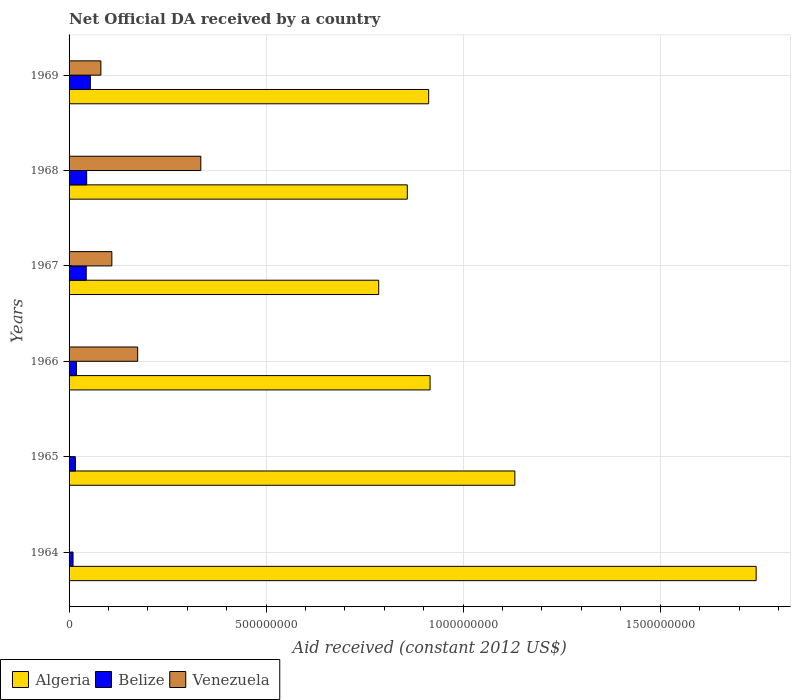How many different coloured bars are there?
Your answer should be very brief. 3. How many groups of bars are there?
Give a very brief answer. 6. Are the number of bars per tick equal to the number of legend labels?
Provide a succinct answer. No. Are the number of bars on each tick of the Y-axis equal?
Make the answer very short. No. How many bars are there on the 4th tick from the top?
Your answer should be compact. 3. What is the label of the 1st group of bars from the top?
Give a very brief answer. 1969. In how many cases, is the number of bars for a given year not equal to the number of legend labels?
Give a very brief answer. 2. What is the net official development assistance aid received in Venezuela in 1965?
Your answer should be compact. 0. Across all years, what is the maximum net official development assistance aid received in Belize?
Offer a very short reply. 5.40e+07. Across all years, what is the minimum net official development assistance aid received in Belize?
Offer a very short reply. 1.01e+07. In which year was the net official development assistance aid received in Venezuela maximum?
Ensure brevity in your answer.  1968. What is the total net official development assistance aid received in Venezuela in the graph?
Give a very brief answer. 6.98e+08. What is the difference between the net official development assistance aid received in Algeria in 1964 and that in 1965?
Make the answer very short. 6.12e+08. What is the difference between the net official development assistance aid received in Venezuela in 1967 and the net official development assistance aid received in Belize in 1968?
Your answer should be very brief. 6.39e+07. What is the average net official development assistance aid received in Belize per year?
Keep it short and to the point. 3.12e+07. In the year 1967, what is the difference between the net official development assistance aid received in Algeria and net official development assistance aid received in Venezuela?
Your answer should be very brief. 6.77e+08. What is the ratio of the net official development assistance aid received in Belize in 1965 to that in 1967?
Ensure brevity in your answer.  0.37. Is the difference between the net official development assistance aid received in Algeria in 1968 and 1969 greater than the difference between the net official development assistance aid received in Venezuela in 1968 and 1969?
Your response must be concise. No. What is the difference between the highest and the second highest net official development assistance aid received in Belize?
Make the answer very short. 9.25e+06. What is the difference between the highest and the lowest net official development assistance aid received in Algeria?
Your answer should be compact. 9.58e+08. In how many years, is the net official development assistance aid received in Algeria greater than the average net official development assistance aid received in Algeria taken over all years?
Keep it short and to the point. 2. How many bars are there?
Your response must be concise. 16. Are all the bars in the graph horizontal?
Ensure brevity in your answer.  Yes. What is the difference between two consecutive major ticks on the X-axis?
Your answer should be very brief. 5.00e+08. Are the values on the major ticks of X-axis written in scientific E-notation?
Keep it short and to the point. No. Does the graph contain grids?
Offer a very short reply. Yes. What is the title of the graph?
Give a very brief answer. Net Official DA received by a country. Does "Ghana" appear as one of the legend labels in the graph?
Your answer should be very brief. No. What is the label or title of the X-axis?
Offer a terse response. Aid received (constant 2012 US$). What is the label or title of the Y-axis?
Provide a succinct answer. Years. What is the Aid received (constant 2012 US$) of Algeria in 1964?
Offer a terse response. 1.74e+09. What is the Aid received (constant 2012 US$) of Belize in 1964?
Provide a succinct answer. 1.01e+07. What is the Aid received (constant 2012 US$) in Venezuela in 1964?
Your response must be concise. 0. What is the Aid received (constant 2012 US$) of Algeria in 1965?
Provide a succinct answer. 1.13e+09. What is the Aid received (constant 2012 US$) in Belize in 1965?
Your answer should be very brief. 1.60e+07. What is the Aid received (constant 2012 US$) of Venezuela in 1965?
Make the answer very short. 0. What is the Aid received (constant 2012 US$) of Algeria in 1966?
Your answer should be compact. 9.16e+08. What is the Aid received (constant 2012 US$) in Belize in 1966?
Your answer should be compact. 1.88e+07. What is the Aid received (constant 2012 US$) of Venezuela in 1966?
Keep it short and to the point. 1.74e+08. What is the Aid received (constant 2012 US$) of Algeria in 1967?
Offer a very short reply. 7.86e+08. What is the Aid received (constant 2012 US$) of Belize in 1967?
Offer a terse response. 4.36e+07. What is the Aid received (constant 2012 US$) of Venezuela in 1967?
Your answer should be compact. 1.09e+08. What is the Aid received (constant 2012 US$) in Algeria in 1968?
Provide a short and direct response. 8.58e+08. What is the Aid received (constant 2012 US$) of Belize in 1968?
Make the answer very short. 4.47e+07. What is the Aid received (constant 2012 US$) in Venezuela in 1968?
Keep it short and to the point. 3.34e+08. What is the Aid received (constant 2012 US$) in Algeria in 1969?
Make the answer very short. 9.12e+08. What is the Aid received (constant 2012 US$) in Belize in 1969?
Your response must be concise. 5.40e+07. What is the Aid received (constant 2012 US$) of Venezuela in 1969?
Provide a succinct answer. 8.07e+07. Across all years, what is the maximum Aid received (constant 2012 US$) in Algeria?
Give a very brief answer. 1.74e+09. Across all years, what is the maximum Aid received (constant 2012 US$) of Belize?
Your answer should be compact. 5.40e+07. Across all years, what is the maximum Aid received (constant 2012 US$) of Venezuela?
Keep it short and to the point. 3.34e+08. Across all years, what is the minimum Aid received (constant 2012 US$) in Algeria?
Keep it short and to the point. 7.86e+08. Across all years, what is the minimum Aid received (constant 2012 US$) in Belize?
Provide a succinct answer. 1.01e+07. What is the total Aid received (constant 2012 US$) in Algeria in the graph?
Your answer should be compact. 6.35e+09. What is the total Aid received (constant 2012 US$) of Belize in the graph?
Offer a very short reply. 1.87e+08. What is the total Aid received (constant 2012 US$) in Venezuela in the graph?
Give a very brief answer. 6.98e+08. What is the difference between the Aid received (constant 2012 US$) in Algeria in 1964 and that in 1965?
Provide a short and direct response. 6.12e+08. What is the difference between the Aid received (constant 2012 US$) in Belize in 1964 and that in 1965?
Offer a very short reply. -5.88e+06. What is the difference between the Aid received (constant 2012 US$) in Algeria in 1964 and that in 1966?
Make the answer very short. 8.27e+08. What is the difference between the Aid received (constant 2012 US$) in Belize in 1964 and that in 1966?
Keep it short and to the point. -8.71e+06. What is the difference between the Aid received (constant 2012 US$) in Algeria in 1964 and that in 1967?
Give a very brief answer. 9.58e+08. What is the difference between the Aid received (constant 2012 US$) of Belize in 1964 and that in 1967?
Keep it short and to the point. -3.35e+07. What is the difference between the Aid received (constant 2012 US$) in Algeria in 1964 and that in 1968?
Ensure brevity in your answer.  8.85e+08. What is the difference between the Aid received (constant 2012 US$) in Belize in 1964 and that in 1968?
Keep it short and to the point. -3.46e+07. What is the difference between the Aid received (constant 2012 US$) in Algeria in 1964 and that in 1969?
Offer a terse response. 8.31e+08. What is the difference between the Aid received (constant 2012 US$) of Belize in 1964 and that in 1969?
Ensure brevity in your answer.  -4.39e+07. What is the difference between the Aid received (constant 2012 US$) in Algeria in 1965 and that in 1966?
Offer a terse response. 2.15e+08. What is the difference between the Aid received (constant 2012 US$) of Belize in 1965 and that in 1966?
Offer a very short reply. -2.83e+06. What is the difference between the Aid received (constant 2012 US$) of Algeria in 1965 and that in 1967?
Your answer should be very brief. 3.45e+08. What is the difference between the Aid received (constant 2012 US$) of Belize in 1965 and that in 1967?
Your response must be concise. -2.76e+07. What is the difference between the Aid received (constant 2012 US$) of Algeria in 1965 and that in 1968?
Offer a very short reply. 2.73e+08. What is the difference between the Aid received (constant 2012 US$) in Belize in 1965 and that in 1968?
Make the answer very short. -2.87e+07. What is the difference between the Aid received (constant 2012 US$) of Algeria in 1965 and that in 1969?
Give a very brief answer. 2.19e+08. What is the difference between the Aid received (constant 2012 US$) in Belize in 1965 and that in 1969?
Make the answer very short. -3.80e+07. What is the difference between the Aid received (constant 2012 US$) of Algeria in 1966 and that in 1967?
Your answer should be very brief. 1.30e+08. What is the difference between the Aid received (constant 2012 US$) of Belize in 1966 and that in 1967?
Offer a terse response. -2.48e+07. What is the difference between the Aid received (constant 2012 US$) of Venezuela in 1966 and that in 1967?
Offer a terse response. 6.55e+07. What is the difference between the Aid received (constant 2012 US$) of Algeria in 1966 and that in 1968?
Ensure brevity in your answer.  5.77e+07. What is the difference between the Aid received (constant 2012 US$) in Belize in 1966 and that in 1968?
Give a very brief answer. -2.59e+07. What is the difference between the Aid received (constant 2012 US$) in Venezuela in 1966 and that in 1968?
Keep it short and to the point. -1.60e+08. What is the difference between the Aid received (constant 2012 US$) in Algeria in 1966 and that in 1969?
Give a very brief answer. 3.54e+06. What is the difference between the Aid received (constant 2012 US$) of Belize in 1966 and that in 1969?
Make the answer very short. -3.52e+07. What is the difference between the Aid received (constant 2012 US$) of Venezuela in 1966 and that in 1969?
Offer a terse response. 9.34e+07. What is the difference between the Aid received (constant 2012 US$) of Algeria in 1967 and that in 1968?
Ensure brevity in your answer.  -7.26e+07. What is the difference between the Aid received (constant 2012 US$) in Belize in 1967 and that in 1968?
Provide a succinct answer. -1.16e+06. What is the difference between the Aid received (constant 2012 US$) of Venezuela in 1967 and that in 1968?
Your response must be concise. -2.26e+08. What is the difference between the Aid received (constant 2012 US$) in Algeria in 1967 and that in 1969?
Your answer should be compact. -1.27e+08. What is the difference between the Aid received (constant 2012 US$) of Belize in 1967 and that in 1969?
Your response must be concise. -1.04e+07. What is the difference between the Aid received (constant 2012 US$) of Venezuela in 1967 and that in 1969?
Your response must be concise. 2.79e+07. What is the difference between the Aid received (constant 2012 US$) in Algeria in 1968 and that in 1969?
Offer a terse response. -5.42e+07. What is the difference between the Aid received (constant 2012 US$) in Belize in 1968 and that in 1969?
Your answer should be compact. -9.25e+06. What is the difference between the Aid received (constant 2012 US$) in Venezuela in 1968 and that in 1969?
Make the answer very short. 2.54e+08. What is the difference between the Aid received (constant 2012 US$) of Algeria in 1964 and the Aid received (constant 2012 US$) of Belize in 1965?
Provide a succinct answer. 1.73e+09. What is the difference between the Aid received (constant 2012 US$) of Algeria in 1964 and the Aid received (constant 2012 US$) of Belize in 1966?
Keep it short and to the point. 1.72e+09. What is the difference between the Aid received (constant 2012 US$) in Algeria in 1964 and the Aid received (constant 2012 US$) in Venezuela in 1966?
Your response must be concise. 1.57e+09. What is the difference between the Aid received (constant 2012 US$) of Belize in 1964 and the Aid received (constant 2012 US$) of Venezuela in 1966?
Offer a very short reply. -1.64e+08. What is the difference between the Aid received (constant 2012 US$) in Algeria in 1964 and the Aid received (constant 2012 US$) in Belize in 1967?
Offer a very short reply. 1.70e+09. What is the difference between the Aid received (constant 2012 US$) in Algeria in 1964 and the Aid received (constant 2012 US$) in Venezuela in 1967?
Provide a short and direct response. 1.63e+09. What is the difference between the Aid received (constant 2012 US$) of Belize in 1964 and the Aid received (constant 2012 US$) of Venezuela in 1967?
Make the answer very short. -9.85e+07. What is the difference between the Aid received (constant 2012 US$) of Algeria in 1964 and the Aid received (constant 2012 US$) of Belize in 1968?
Your answer should be compact. 1.70e+09. What is the difference between the Aid received (constant 2012 US$) of Algeria in 1964 and the Aid received (constant 2012 US$) of Venezuela in 1968?
Provide a succinct answer. 1.41e+09. What is the difference between the Aid received (constant 2012 US$) in Belize in 1964 and the Aid received (constant 2012 US$) in Venezuela in 1968?
Ensure brevity in your answer.  -3.24e+08. What is the difference between the Aid received (constant 2012 US$) of Algeria in 1964 and the Aid received (constant 2012 US$) of Belize in 1969?
Your response must be concise. 1.69e+09. What is the difference between the Aid received (constant 2012 US$) in Algeria in 1964 and the Aid received (constant 2012 US$) in Venezuela in 1969?
Offer a terse response. 1.66e+09. What is the difference between the Aid received (constant 2012 US$) of Belize in 1964 and the Aid received (constant 2012 US$) of Venezuela in 1969?
Ensure brevity in your answer.  -7.06e+07. What is the difference between the Aid received (constant 2012 US$) of Algeria in 1965 and the Aid received (constant 2012 US$) of Belize in 1966?
Provide a short and direct response. 1.11e+09. What is the difference between the Aid received (constant 2012 US$) in Algeria in 1965 and the Aid received (constant 2012 US$) in Venezuela in 1966?
Ensure brevity in your answer.  9.57e+08. What is the difference between the Aid received (constant 2012 US$) of Belize in 1965 and the Aid received (constant 2012 US$) of Venezuela in 1966?
Ensure brevity in your answer.  -1.58e+08. What is the difference between the Aid received (constant 2012 US$) in Algeria in 1965 and the Aid received (constant 2012 US$) in Belize in 1967?
Provide a short and direct response. 1.09e+09. What is the difference between the Aid received (constant 2012 US$) of Algeria in 1965 and the Aid received (constant 2012 US$) of Venezuela in 1967?
Keep it short and to the point. 1.02e+09. What is the difference between the Aid received (constant 2012 US$) in Belize in 1965 and the Aid received (constant 2012 US$) in Venezuela in 1967?
Give a very brief answer. -9.26e+07. What is the difference between the Aid received (constant 2012 US$) of Algeria in 1965 and the Aid received (constant 2012 US$) of Belize in 1968?
Your answer should be very brief. 1.09e+09. What is the difference between the Aid received (constant 2012 US$) in Algeria in 1965 and the Aid received (constant 2012 US$) in Venezuela in 1968?
Offer a very short reply. 7.97e+08. What is the difference between the Aid received (constant 2012 US$) of Belize in 1965 and the Aid received (constant 2012 US$) of Venezuela in 1968?
Offer a very short reply. -3.18e+08. What is the difference between the Aid received (constant 2012 US$) in Algeria in 1965 and the Aid received (constant 2012 US$) in Belize in 1969?
Keep it short and to the point. 1.08e+09. What is the difference between the Aid received (constant 2012 US$) in Algeria in 1965 and the Aid received (constant 2012 US$) in Venezuela in 1969?
Provide a succinct answer. 1.05e+09. What is the difference between the Aid received (constant 2012 US$) of Belize in 1965 and the Aid received (constant 2012 US$) of Venezuela in 1969?
Keep it short and to the point. -6.47e+07. What is the difference between the Aid received (constant 2012 US$) of Algeria in 1966 and the Aid received (constant 2012 US$) of Belize in 1967?
Your answer should be very brief. 8.72e+08. What is the difference between the Aid received (constant 2012 US$) of Algeria in 1966 and the Aid received (constant 2012 US$) of Venezuela in 1967?
Provide a succinct answer. 8.07e+08. What is the difference between the Aid received (constant 2012 US$) of Belize in 1966 and the Aid received (constant 2012 US$) of Venezuela in 1967?
Provide a succinct answer. -8.98e+07. What is the difference between the Aid received (constant 2012 US$) of Algeria in 1966 and the Aid received (constant 2012 US$) of Belize in 1968?
Offer a very short reply. 8.71e+08. What is the difference between the Aid received (constant 2012 US$) of Algeria in 1966 and the Aid received (constant 2012 US$) of Venezuela in 1968?
Keep it short and to the point. 5.82e+08. What is the difference between the Aid received (constant 2012 US$) of Belize in 1966 and the Aid received (constant 2012 US$) of Venezuela in 1968?
Ensure brevity in your answer.  -3.16e+08. What is the difference between the Aid received (constant 2012 US$) of Algeria in 1966 and the Aid received (constant 2012 US$) of Belize in 1969?
Your answer should be very brief. 8.62e+08. What is the difference between the Aid received (constant 2012 US$) of Algeria in 1966 and the Aid received (constant 2012 US$) of Venezuela in 1969?
Make the answer very short. 8.35e+08. What is the difference between the Aid received (constant 2012 US$) in Belize in 1966 and the Aid received (constant 2012 US$) in Venezuela in 1969?
Give a very brief answer. -6.19e+07. What is the difference between the Aid received (constant 2012 US$) in Algeria in 1967 and the Aid received (constant 2012 US$) in Belize in 1968?
Your response must be concise. 7.41e+08. What is the difference between the Aid received (constant 2012 US$) in Algeria in 1967 and the Aid received (constant 2012 US$) in Venezuela in 1968?
Your response must be concise. 4.51e+08. What is the difference between the Aid received (constant 2012 US$) of Belize in 1967 and the Aid received (constant 2012 US$) of Venezuela in 1968?
Your response must be concise. -2.91e+08. What is the difference between the Aid received (constant 2012 US$) in Algeria in 1967 and the Aid received (constant 2012 US$) in Belize in 1969?
Your response must be concise. 7.32e+08. What is the difference between the Aid received (constant 2012 US$) of Algeria in 1967 and the Aid received (constant 2012 US$) of Venezuela in 1969?
Your response must be concise. 7.05e+08. What is the difference between the Aid received (constant 2012 US$) in Belize in 1967 and the Aid received (constant 2012 US$) in Venezuela in 1969?
Ensure brevity in your answer.  -3.72e+07. What is the difference between the Aid received (constant 2012 US$) in Algeria in 1968 and the Aid received (constant 2012 US$) in Belize in 1969?
Your answer should be very brief. 8.04e+08. What is the difference between the Aid received (constant 2012 US$) in Algeria in 1968 and the Aid received (constant 2012 US$) in Venezuela in 1969?
Give a very brief answer. 7.78e+08. What is the difference between the Aid received (constant 2012 US$) of Belize in 1968 and the Aid received (constant 2012 US$) of Venezuela in 1969?
Provide a short and direct response. -3.60e+07. What is the average Aid received (constant 2012 US$) in Algeria per year?
Provide a succinct answer. 1.06e+09. What is the average Aid received (constant 2012 US$) of Belize per year?
Offer a terse response. 3.12e+07. What is the average Aid received (constant 2012 US$) of Venezuela per year?
Provide a succinct answer. 1.16e+08. In the year 1964, what is the difference between the Aid received (constant 2012 US$) of Algeria and Aid received (constant 2012 US$) of Belize?
Ensure brevity in your answer.  1.73e+09. In the year 1965, what is the difference between the Aid received (constant 2012 US$) of Algeria and Aid received (constant 2012 US$) of Belize?
Give a very brief answer. 1.12e+09. In the year 1966, what is the difference between the Aid received (constant 2012 US$) of Algeria and Aid received (constant 2012 US$) of Belize?
Provide a short and direct response. 8.97e+08. In the year 1966, what is the difference between the Aid received (constant 2012 US$) in Algeria and Aid received (constant 2012 US$) in Venezuela?
Give a very brief answer. 7.42e+08. In the year 1966, what is the difference between the Aid received (constant 2012 US$) of Belize and Aid received (constant 2012 US$) of Venezuela?
Give a very brief answer. -1.55e+08. In the year 1967, what is the difference between the Aid received (constant 2012 US$) of Algeria and Aid received (constant 2012 US$) of Belize?
Your answer should be compact. 7.42e+08. In the year 1967, what is the difference between the Aid received (constant 2012 US$) in Algeria and Aid received (constant 2012 US$) in Venezuela?
Your response must be concise. 6.77e+08. In the year 1967, what is the difference between the Aid received (constant 2012 US$) in Belize and Aid received (constant 2012 US$) in Venezuela?
Keep it short and to the point. -6.50e+07. In the year 1968, what is the difference between the Aid received (constant 2012 US$) of Algeria and Aid received (constant 2012 US$) of Belize?
Offer a very short reply. 8.14e+08. In the year 1968, what is the difference between the Aid received (constant 2012 US$) of Algeria and Aid received (constant 2012 US$) of Venezuela?
Your answer should be compact. 5.24e+08. In the year 1968, what is the difference between the Aid received (constant 2012 US$) of Belize and Aid received (constant 2012 US$) of Venezuela?
Make the answer very short. -2.90e+08. In the year 1969, what is the difference between the Aid received (constant 2012 US$) in Algeria and Aid received (constant 2012 US$) in Belize?
Make the answer very short. 8.59e+08. In the year 1969, what is the difference between the Aid received (constant 2012 US$) of Algeria and Aid received (constant 2012 US$) of Venezuela?
Keep it short and to the point. 8.32e+08. In the year 1969, what is the difference between the Aid received (constant 2012 US$) in Belize and Aid received (constant 2012 US$) in Venezuela?
Provide a short and direct response. -2.67e+07. What is the ratio of the Aid received (constant 2012 US$) in Algeria in 1964 to that in 1965?
Offer a terse response. 1.54. What is the ratio of the Aid received (constant 2012 US$) in Belize in 1964 to that in 1965?
Ensure brevity in your answer.  0.63. What is the ratio of the Aid received (constant 2012 US$) in Algeria in 1964 to that in 1966?
Your answer should be compact. 1.9. What is the ratio of the Aid received (constant 2012 US$) in Belize in 1964 to that in 1966?
Ensure brevity in your answer.  0.54. What is the ratio of the Aid received (constant 2012 US$) of Algeria in 1964 to that in 1967?
Provide a succinct answer. 2.22. What is the ratio of the Aid received (constant 2012 US$) in Belize in 1964 to that in 1967?
Your answer should be very brief. 0.23. What is the ratio of the Aid received (constant 2012 US$) of Algeria in 1964 to that in 1968?
Offer a very short reply. 2.03. What is the ratio of the Aid received (constant 2012 US$) in Belize in 1964 to that in 1968?
Your response must be concise. 0.23. What is the ratio of the Aid received (constant 2012 US$) of Algeria in 1964 to that in 1969?
Your response must be concise. 1.91. What is the ratio of the Aid received (constant 2012 US$) of Belize in 1964 to that in 1969?
Make the answer very short. 0.19. What is the ratio of the Aid received (constant 2012 US$) in Algeria in 1965 to that in 1966?
Your answer should be very brief. 1.23. What is the ratio of the Aid received (constant 2012 US$) in Belize in 1965 to that in 1966?
Give a very brief answer. 0.85. What is the ratio of the Aid received (constant 2012 US$) of Algeria in 1965 to that in 1967?
Provide a succinct answer. 1.44. What is the ratio of the Aid received (constant 2012 US$) in Belize in 1965 to that in 1967?
Offer a very short reply. 0.37. What is the ratio of the Aid received (constant 2012 US$) of Algeria in 1965 to that in 1968?
Your answer should be compact. 1.32. What is the ratio of the Aid received (constant 2012 US$) of Belize in 1965 to that in 1968?
Offer a terse response. 0.36. What is the ratio of the Aid received (constant 2012 US$) of Algeria in 1965 to that in 1969?
Your response must be concise. 1.24. What is the ratio of the Aid received (constant 2012 US$) of Belize in 1965 to that in 1969?
Your response must be concise. 0.3. What is the ratio of the Aid received (constant 2012 US$) of Algeria in 1966 to that in 1967?
Offer a terse response. 1.17. What is the ratio of the Aid received (constant 2012 US$) in Belize in 1966 to that in 1967?
Offer a terse response. 0.43. What is the ratio of the Aid received (constant 2012 US$) in Venezuela in 1966 to that in 1967?
Ensure brevity in your answer.  1.6. What is the ratio of the Aid received (constant 2012 US$) of Algeria in 1966 to that in 1968?
Ensure brevity in your answer.  1.07. What is the ratio of the Aid received (constant 2012 US$) of Belize in 1966 to that in 1968?
Offer a very short reply. 0.42. What is the ratio of the Aid received (constant 2012 US$) in Venezuela in 1966 to that in 1968?
Your response must be concise. 0.52. What is the ratio of the Aid received (constant 2012 US$) in Algeria in 1966 to that in 1969?
Provide a succinct answer. 1. What is the ratio of the Aid received (constant 2012 US$) in Belize in 1966 to that in 1969?
Offer a terse response. 0.35. What is the ratio of the Aid received (constant 2012 US$) of Venezuela in 1966 to that in 1969?
Offer a very short reply. 2.16. What is the ratio of the Aid received (constant 2012 US$) of Algeria in 1967 to that in 1968?
Offer a terse response. 0.92. What is the ratio of the Aid received (constant 2012 US$) of Belize in 1967 to that in 1968?
Ensure brevity in your answer.  0.97. What is the ratio of the Aid received (constant 2012 US$) of Venezuela in 1967 to that in 1968?
Your answer should be compact. 0.32. What is the ratio of the Aid received (constant 2012 US$) in Algeria in 1967 to that in 1969?
Make the answer very short. 0.86. What is the ratio of the Aid received (constant 2012 US$) of Belize in 1967 to that in 1969?
Your answer should be very brief. 0.81. What is the ratio of the Aid received (constant 2012 US$) of Venezuela in 1967 to that in 1969?
Offer a very short reply. 1.35. What is the ratio of the Aid received (constant 2012 US$) in Algeria in 1968 to that in 1969?
Make the answer very short. 0.94. What is the ratio of the Aid received (constant 2012 US$) of Belize in 1968 to that in 1969?
Give a very brief answer. 0.83. What is the ratio of the Aid received (constant 2012 US$) of Venezuela in 1968 to that in 1969?
Provide a short and direct response. 4.14. What is the difference between the highest and the second highest Aid received (constant 2012 US$) in Algeria?
Give a very brief answer. 6.12e+08. What is the difference between the highest and the second highest Aid received (constant 2012 US$) in Belize?
Your answer should be very brief. 9.25e+06. What is the difference between the highest and the second highest Aid received (constant 2012 US$) in Venezuela?
Offer a terse response. 1.60e+08. What is the difference between the highest and the lowest Aid received (constant 2012 US$) in Algeria?
Offer a terse response. 9.58e+08. What is the difference between the highest and the lowest Aid received (constant 2012 US$) in Belize?
Your answer should be very brief. 4.39e+07. What is the difference between the highest and the lowest Aid received (constant 2012 US$) in Venezuela?
Ensure brevity in your answer.  3.34e+08. 